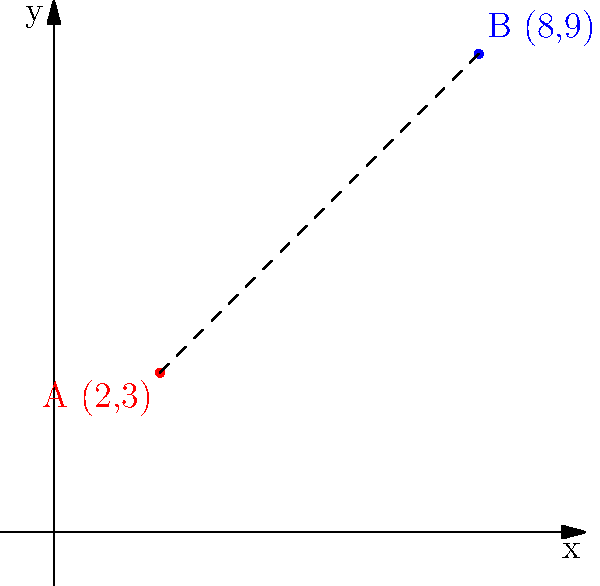As a local business owner committed to bridging socioeconomic gaps, you're analyzing the distance between two communities represented by points on a coordinate plane. Point A (2,3) represents a low-income neighborhood, while point B (8,9) represents an affluent area. Calculate the distance between these two points to quantify the socioeconomic disparity. Round your answer to two decimal places. To find the distance between two points on a coordinate plane, we use the distance formula:

$$d = \sqrt{(x_2 - x_1)^2 + (y_2 - y_1)^2}$$

Where $(x_1, y_1)$ is the first point and $(x_2, y_2)$ is the second point.

Given:
Point A: $(2, 3)$
Point B: $(8, 9)$

Step 1: Identify the coordinates
$x_1 = 2$, $y_1 = 3$
$x_2 = 8$, $y_2 = 9$

Step 2: Substitute these values into the distance formula
$$d = \sqrt{(8 - 2)^2 + (9 - 3)^2}$$

Step 3: Simplify the expressions inside the parentheses
$$d = \sqrt{6^2 + 6^2}$$

Step 4: Calculate the squares
$$d = \sqrt{36 + 36}$$

Step 5: Add the values under the square root
$$d = \sqrt{72}$$

Step 6: Simplify the square root
$$d = 6\sqrt{2}$$

Step 7: Calculate the approximate value and round to two decimal places
$$d \approx 8.49$$

This distance represents the socioeconomic gap between the two communities.
Answer: 8.49 units 